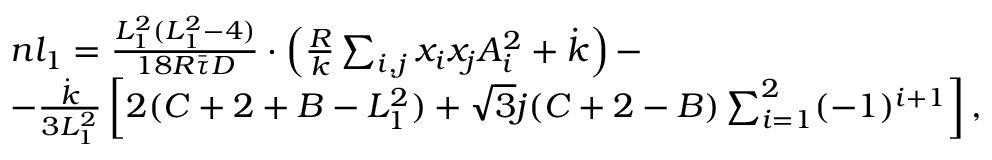Convert formula to latex. <formula><loc_0><loc_0><loc_500><loc_500>\begin{array} { r l } & { n l _ { 1 } = \frac { L _ { 1 } ^ { 2 } ( L _ { 1 } ^ { 2 } - 4 ) } { 1 8 R \bar { \tau } D } \cdot \left ( \frac { R } { k } \sum _ { i , j } x _ { i } x _ { j } A _ { i } ^ { 2 } + \dot { k } \right ) - } \\ & { - \frac { \dot { k } } { 3 L _ { 1 } ^ { 2 } } \left [ 2 ( C + 2 + B - L _ { 1 } ^ { 2 } ) + \sqrt { 3 } j ( C + 2 - B ) \sum _ { i = 1 } ^ { 2 } ( - 1 ) ^ { i + 1 } \right ] , } \end{array}</formula> 